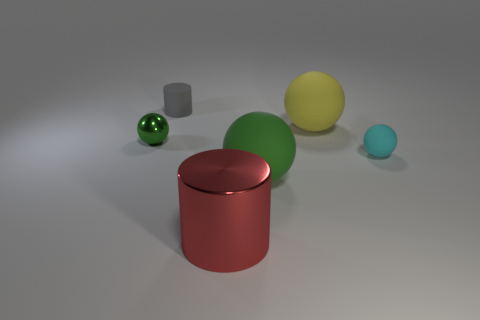Add 1 tiny blue rubber cylinders. How many objects exist? 7 Subtract all brown balls. Subtract all green cubes. How many balls are left? 4 Subtract all spheres. How many objects are left? 2 Add 2 red metallic things. How many red metallic things are left? 3 Add 2 tiny green balls. How many tiny green balls exist? 3 Subtract 0 brown blocks. How many objects are left? 6 Subtract all shiny cylinders. Subtract all large red matte cylinders. How many objects are left? 5 